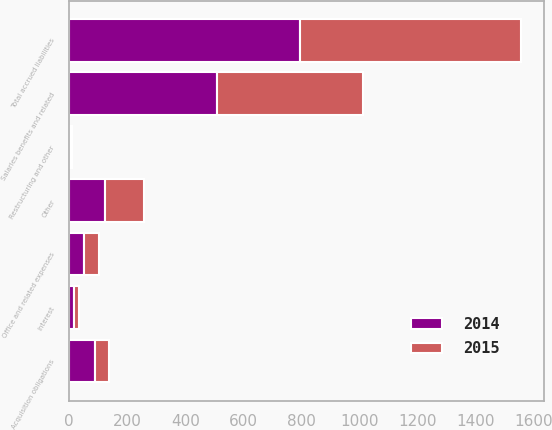Convert chart. <chart><loc_0><loc_0><loc_500><loc_500><stacked_bar_chart><ecel><fcel>Salaries benefits and related<fcel>Office and related expenses<fcel>Acquisition obligations<fcel>Interest<fcel>Restructuring and other<fcel>Other<fcel>Total accrued liabilities<nl><fcel>2015<fcel>502.4<fcel>51<fcel>50.1<fcel>17.3<fcel>3.3<fcel>136.2<fcel>760.3<nl><fcel>2014<fcel>510.6<fcel>51.5<fcel>88.1<fcel>18.3<fcel>5.5<fcel>122<fcel>796<nl></chart> 